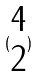Convert formula to latex. <formula><loc_0><loc_0><loc_500><loc_500>( \begin{matrix} 4 \\ 2 \end{matrix} )</formula> 